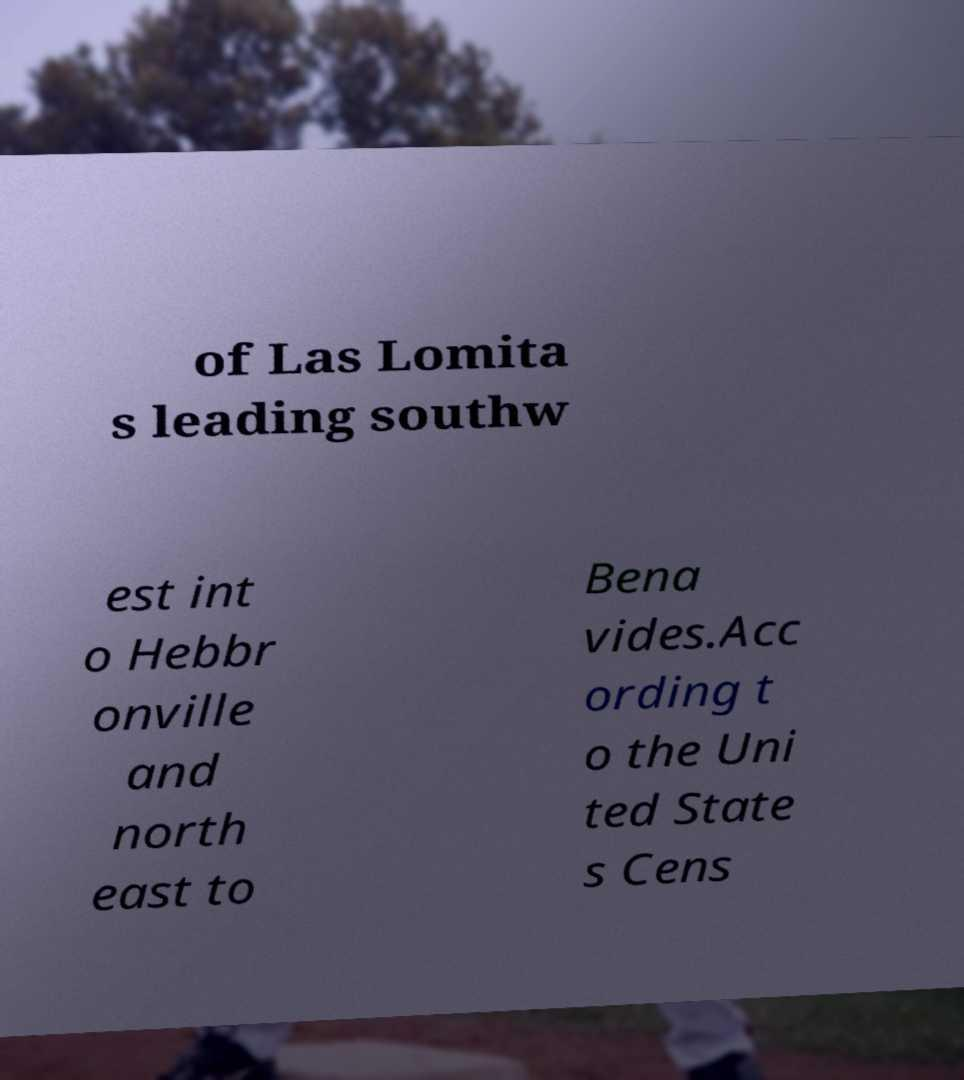There's text embedded in this image that I need extracted. Can you transcribe it verbatim? of Las Lomita s leading southw est int o Hebbr onville and north east to Bena vides.Acc ording t o the Uni ted State s Cens 